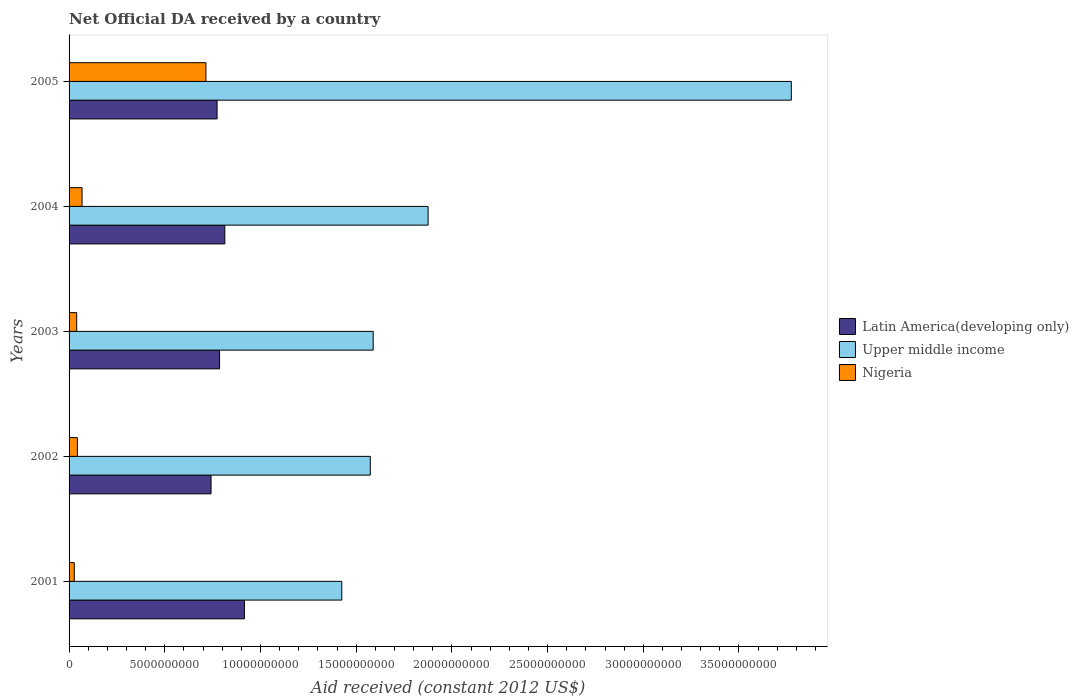How many groups of bars are there?
Offer a terse response. 5. How many bars are there on the 2nd tick from the top?
Your response must be concise. 3. What is the label of the 2nd group of bars from the top?
Offer a terse response. 2004. In how many cases, is the number of bars for a given year not equal to the number of legend labels?
Provide a short and direct response. 0. What is the net official development assistance aid received in Latin America(developing only) in 2004?
Offer a very short reply. 8.14e+09. Across all years, what is the maximum net official development assistance aid received in Nigeria?
Your answer should be compact. 7.15e+09. Across all years, what is the minimum net official development assistance aid received in Latin America(developing only)?
Provide a succinct answer. 7.42e+09. In which year was the net official development assistance aid received in Latin America(developing only) minimum?
Keep it short and to the point. 2002. What is the total net official development assistance aid received in Latin America(developing only) in the graph?
Keep it short and to the point. 4.03e+1. What is the difference between the net official development assistance aid received in Nigeria in 2001 and that in 2002?
Your answer should be very brief. -1.63e+08. What is the difference between the net official development assistance aid received in Latin America(developing only) in 2005 and the net official development assistance aid received in Upper middle income in 2001?
Provide a short and direct response. -6.52e+09. What is the average net official development assistance aid received in Latin America(developing only) per year?
Your answer should be very brief. 8.06e+09. In the year 2004, what is the difference between the net official development assistance aid received in Nigeria and net official development assistance aid received in Latin America(developing only)?
Make the answer very short. -7.46e+09. What is the ratio of the net official development assistance aid received in Nigeria in 2001 to that in 2002?
Provide a succinct answer. 0.63. Is the net official development assistance aid received in Upper middle income in 2001 less than that in 2004?
Provide a succinct answer. Yes. Is the difference between the net official development assistance aid received in Nigeria in 2001 and 2002 greater than the difference between the net official development assistance aid received in Latin America(developing only) in 2001 and 2002?
Your answer should be compact. No. What is the difference between the highest and the second highest net official development assistance aid received in Upper middle income?
Ensure brevity in your answer.  1.90e+1. What is the difference between the highest and the lowest net official development assistance aid received in Nigeria?
Provide a succinct answer. 6.88e+09. Is the sum of the net official development assistance aid received in Upper middle income in 2001 and 2004 greater than the maximum net official development assistance aid received in Nigeria across all years?
Offer a terse response. Yes. What does the 1st bar from the top in 2001 represents?
Offer a terse response. Nigeria. What does the 1st bar from the bottom in 2002 represents?
Ensure brevity in your answer.  Latin America(developing only). Is it the case that in every year, the sum of the net official development assistance aid received in Latin America(developing only) and net official development assistance aid received in Upper middle income is greater than the net official development assistance aid received in Nigeria?
Your answer should be compact. Yes. How many bars are there?
Offer a terse response. 15. Are all the bars in the graph horizontal?
Your answer should be very brief. Yes. Are the values on the major ticks of X-axis written in scientific E-notation?
Provide a short and direct response. No. How many legend labels are there?
Your answer should be compact. 3. How are the legend labels stacked?
Give a very brief answer. Vertical. What is the title of the graph?
Your response must be concise. Net Official DA received by a country. What is the label or title of the X-axis?
Your answer should be compact. Aid received (constant 2012 US$). What is the Aid received (constant 2012 US$) of Latin America(developing only) in 2001?
Provide a succinct answer. 9.16e+09. What is the Aid received (constant 2012 US$) in Upper middle income in 2001?
Offer a terse response. 1.42e+1. What is the Aid received (constant 2012 US$) of Nigeria in 2001?
Provide a succinct answer. 2.72e+08. What is the Aid received (constant 2012 US$) of Latin America(developing only) in 2002?
Offer a terse response. 7.42e+09. What is the Aid received (constant 2012 US$) in Upper middle income in 2002?
Make the answer very short. 1.57e+1. What is the Aid received (constant 2012 US$) in Nigeria in 2002?
Offer a terse response. 4.34e+08. What is the Aid received (constant 2012 US$) in Latin America(developing only) in 2003?
Ensure brevity in your answer.  7.86e+09. What is the Aid received (constant 2012 US$) in Upper middle income in 2003?
Offer a very short reply. 1.59e+1. What is the Aid received (constant 2012 US$) in Nigeria in 2003?
Your answer should be compact. 3.99e+08. What is the Aid received (constant 2012 US$) of Latin America(developing only) in 2004?
Your response must be concise. 8.14e+09. What is the Aid received (constant 2012 US$) of Upper middle income in 2004?
Your response must be concise. 1.88e+1. What is the Aid received (constant 2012 US$) in Nigeria in 2004?
Ensure brevity in your answer.  6.79e+08. What is the Aid received (constant 2012 US$) in Latin America(developing only) in 2005?
Your response must be concise. 7.73e+09. What is the Aid received (constant 2012 US$) in Upper middle income in 2005?
Give a very brief answer. 3.77e+1. What is the Aid received (constant 2012 US$) of Nigeria in 2005?
Ensure brevity in your answer.  7.15e+09. Across all years, what is the maximum Aid received (constant 2012 US$) of Latin America(developing only)?
Ensure brevity in your answer.  9.16e+09. Across all years, what is the maximum Aid received (constant 2012 US$) of Upper middle income?
Your answer should be very brief. 3.77e+1. Across all years, what is the maximum Aid received (constant 2012 US$) of Nigeria?
Keep it short and to the point. 7.15e+09. Across all years, what is the minimum Aid received (constant 2012 US$) in Latin America(developing only)?
Give a very brief answer. 7.42e+09. Across all years, what is the minimum Aid received (constant 2012 US$) of Upper middle income?
Provide a short and direct response. 1.42e+1. Across all years, what is the minimum Aid received (constant 2012 US$) of Nigeria?
Offer a terse response. 2.72e+08. What is the total Aid received (constant 2012 US$) in Latin America(developing only) in the graph?
Make the answer very short. 4.03e+1. What is the total Aid received (constant 2012 US$) of Upper middle income in the graph?
Your answer should be very brief. 1.02e+11. What is the total Aid received (constant 2012 US$) in Nigeria in the graph?
Provide a succinct answer. 8.93e+09. What is the difference between the Aid received (constant 2012 US$) in Latin America(developing only) in 2001 and that in 2002?
Provide a short and direct response. 1.74e+09. What is the difference between the Aid received (constant 2012 US$) of Upper middle income in 2001 and that in 2002?
Make the answer very short. -1.49e+09. What is the difference between the Aid received (constant 2012 US$) of Nigeria in 2001 and that in 2002?
Your response must be concise. -1.63e+08. What is the difference between the Aid received (constant 2012 US$) of Latin America(developing only) in 2001 and that in 2003?
Offer a terse response. 1.30e+09. What is the difference between the Aid received (constant 2012 US$) in Upper middle income in 2001 and that in 2003?
Offer a very short reply. -1.64e+09. What is the difference between the Aid received (constant 2012 US$) in Nigeria in 2001 and that in 2003?
Your response must be concise. -1.27e+08. What is the difference between the Aid received (constant 2012 US$) in Latin America(developing only) in 2001 and that in 2004?
Give a very brief answer. 1.03e+09. What is the difference between the Aid received (constant 2012 US$) of Upper middle income in 2001 and that in 2004?
Your answer should be very brief. -4.51e+09. What is the difference between the Aid received (constant 2012 US$) of Nigeria in 2001 and that in 2004?
Your answer should be compact. -4.07e+08. What is the difference between the Aid received (constant 2012 US$) in Latin America(developing only) in 2001 and that in 2005?
Offer a terse response. 1.43e+09. What is the difference between the Aid received (constant 2012 US$) of Upper middle income in 2001 and that in 2005?
Keep it short and to the point. -2.35e+1. What is the difference between the Aid received (constant 2012 US$) in Nigeria in 2001 and that in 2005?
Offer a terse response. -6.88e+09. What is the difference between the Aid received (constant 2012 US$) of Latin America(developing only) in 2002 and that in 2003?
Offer a terse response. -4.43e+08. What is the difference between the Aid received (constant 2012 US$) in Upper middle income in 2002 and that in 2003?
Provide a succinct answer. -1.50e+08. What is the difference between the Aid received (constant 2012 US$) in Nigeria in 2002 and that in 2003?
Make the answer very short. 3.58e+07. What is the difference between the Aid received (constant 2012 US$) of Latin America(developing only) in 2002 and that in 2004?
Your answer should be very brief. -7.19e+08. What is the difference between the Aid received (constant 2012 US$) of Upper middle income in 2002 and that in 2004?
Provide a succinct answer. -3.02e+09. What is the difference between the Aid received (constant 2012 US$) of Nigeria in 2002 and that in 2004?
Your answer should be very brief. -2.44e+08. What is the difference between the Aid received (constant 2012 US$) of Latin America(developing only) in 2002 and that in 2005?
Give a very brief answer. -3.15e+08. What is the difference between the Aid received (constant 2012 US$) in Upper middle income in 2002 and that in 2005?
Ensure brevity in your answer.  -2.20e+1. What is the difference between the Aid received (constant 2012 US$) in Nigeria in 2002 and that in 2005?
Offer a very short reply. -6.72e+09. What is the difference between the Aid received (constant 2012 US$) in Latin America(developing only) in 2003 and that in 2004?
Your answer should be compact. -2.75e+08. What is the difference between the Aid received (constant 2012 US$) in Upper middle income in 2003 and that in 2004?
Provide a succinct answer. -2.87e+09. What is the difference between the Aid received (constant 2012 US$) in Nigeria in 2003 and that in 2004?
Offer a terse response. -2.80e+08. What is the difference between the Aid received (constant 2012 US$) in Latin America(developing only) in 2003 and that in 2005?
Offer a terse response. 1.29e+08. What is the difference between the Aid received (constant 2012 US$) in Upper middle income in 2003 and that in 2005?
Give a very brief answer. -2.18e+1. What is the difference between the Aid received (constant 2012 US$) in Nigeria in 2003 and that in 2005?
Your answer should be compact. -6.75e+09. What is the difference between the Aid received (constant 2012 US$) of Latin America(developing only) in 2004 and that in 2005?
Ensure brevity in your answer.  4.04e+08. What is the difference between the Aid received (constant 2012 US$) of Upper middle income in 2004 and that in 2005?
Provide a succinct answer. -1.90e+1. What is the difference between the Aid received (constant 2012 US$) in Nigeria in 2004 and that in 2005?
Keep it short and to the point. -6.47e+09. What is the difference between the Aid received (constant 2012 US$) in Latin America(developing only) in 2001 and the Aid received (constant 2012 US$) in Upper middle income in 2002?
Offer a very short reply. -6.58e+09. What is the difference between the Aid received (constant 2012 US$) in Latin America(developing only) in 2001 and the Aid received (constant 2012 US$) in Nigeria in 2002?
Provide a short and direct response. 8.73e+09. What is the difference between the Aid received (constant 2012 US$) of Upper middle income in 2001 and the Aid received (constant 2012 US$) of Nigeria in 2002?
Give a very brief answer. 1.38e+1. What is the difference between the Aid received (constant 2012 US$) in Latin America(developing only) in 2001 and the Aid received (constant 2012 US$) in Upper middle income in 2003?
Provide a short and direct response. -6.73e+09. What is the difference between the Aid received (constant 2012 US$) of Latin America(developing only) in 2001 and the Aid received (constant 2012 US$) of Nigeria in 2003?
Ensure brevity in your answer.  8.76e+09. What is the difference between the Aid received (constant 2012 US$) in Upper middle income in 2001 and the Aid received (constant 2012 US$) in Nigeria in 2003?
Provide a succinct answer. 1.38e+1. What is the difference between the Aid received (constant 2012 US$) of Latin America(developing only) in 2001 and the Aid received (constant 2012 US$) of Upper middle income in 2004?
Your response must be concise. -9.59e+09. What is the difference between the Aid received (constant 2012 US$) of Latin America(developing only) in 2001 and the Aid received (constant 2012 US$) of Nigeria in 2004?
Your answer should be compact. 8.48e+09. What is the difference between the Aid received (constant 2012 US$) of Upper middle income in 2001 and the Aid received (constant 2012 US$) of Nigeria in 2004?
Ensure brevity in your answer.  1.36e+1. What is the difference between the Aid received (constant 2012 US$) of Latin America(developing only) in 2001 and the Aid received (constant 2012 US$) of Upper middle income in 2005?
Offer a very short reply. -2.86e+1. What is the difference between the Aid received (constant 2012 US$) of Latin America(developing only) in 2001 and the Aid received (constant 2012 US$) of Nigeria in 2005?
Your answer should be compact. 2.01e+09. What is the difference between the Aid received (constant 2012 US$) of Upper middle income in 2001 and the Aid received (constant 2012 US$) of Nigeria in 2005?
Offer a very short reply. 7.10e+09. What is the difference between the Aid received (constant 2012 US$) in Latin America(developing only) in 2002 and the Aid received (constant 2012 US$) in Upper middle income in 2003?
Provide a succinct answer. -8.47e+09. What is the difference between the Aid received (constant 2012 US$) of Latin America(developing only) in 2002 and the Aid received (constant 2012 US$) of Nigeria in 2003?
Your response must be concise. 7.02e+09. What is the difference between the Aid received (constant 2012 US$) in Upper middle income in 2002 and the Aid received (constant 2012 US$) in Nigeria in 2003?
Make the answer very short. 1.53e+1. What is the difference between the Aid received (constant 2012 US$) of Latin America(developing only) in 2002 and the Aid received (constant 2012 US$) of Upper middle income in 2004?
Keep it short and to the point. -1.13e+1. What is the difference between the Aid received (constant 2012 US$) in Latin America(developing only) in 2002 and the Aid received (constant 2012 US$) in Nigeria in 2004?
Offer a terse response. 6.74e+09. What is the difference between the Aid received (constant 2012 US$) in Upper middle income in 2002 and the Aid received (constant 2012 US$) in Nigeria in 2004?
Give a very brief answer. 1.51e+1. What is the difference between the Aid received (constant 2012 US$) of Latin America(developing only) in 2002 and the Aid received (constant 2012 US$) of Upper middle income in 2005?
Provide a succinct answer. -3.03e+1. What is the difference between the Aid received (constant 2012 US$) in Latin America(developing only) in 2002 and the Aid received (constant 2012 US$) in Nigeria in 2005?
Make the answer very short. 2.68e+08. What is the difference between the Aid received (constant 2012 US$) in Upper middle income in 2002 and the Aid received (constant 2012 US$) in Nigeria in 2005?
Your response must be concise. 8.59e+09. What is the difference between the Aid received (constant 2012 US$) in Latin America(developing only) in 2003 and the Aid received (constant 2012 US$) in Upper middle income in 2004?
Your answer should be very brief. -1.09e+1. What is the difference between the Aid received (constant 2012 US$) of Latin America(developing only) in 2003 and the Aid received (constant 2012 US$) of Nigeria in 2004?
Offer a terse response. 7.18e+09. What is the difference between the Aid received (constant 2012 US$) of Upper middle income in 2003 and the Aid received (constant 2012 US$) of Nigeria in 2004?
Provide a succinct answer. 1.52e+1. What is the difference between the Aid received (constant 2012 US$) in Latin America(developing only) in 2003 and the Aid received (constant 2012 US$) in Upper middle income in 2005?
Your answer should be very brief. -2.99e+1. What is the difference between the Aid received (constant 2012 US$) in Latin America(developing only) in 2003 and the Aid received (constant 2012 US$) in Nigeria in 2005?
Your answer should be compact. 7.12e+08. What is the difference between the Aid received (constant 2012 US$) of Upper middle income in 2003 and the Aid received (constant 2012 US$) of Nigeria in 2005?
Your answer should be compact. 8.74e+09. What is the difference between the Aid received (constant 2012 US$) in Latin America(developing only) in 2004 and the Aid received (constant 2012 US$) in Upper middle income in 2005?
Keep it short and to the point. -2.96e+1. What is the difference between the Aid received (constant 2012 US$) in Latin America(developing only) in 2004 and the Aid received (constant 2012 US$) in Nigeria in 2005?
Ensure brevity in your answer.  9.87e+08. What is the difference between the Aid received (constant 2012 US$) of Upper middle income in 2004 and the Aid received (constant 2012 US$) of Nigeria in 2005?
Make the answer very short. 1.16e+1. What is the average Aid received (constant 2012 US$) of Latin America(developing only) per year?
Offer a very short reply. 8.06e+09. What is the average Aid received (constant 2012 US$) in Upper middle income per year?
Your answer should be very brief. 2.05e+1. What is the average Aid received (constant 2012 US$) in Nigeria per year?
Provide a succinct answer. 1.79e+09. In the year 2001, what is the difference between the Aid received (constant 2012 US$) in Latin America(developing only) and Aid received (constant 2012 US$) in Upper middle income?
Give a very brief answer. -5.09e+09. In the year 2001, what is the difference between the Aid received (constant 2012 US$) of Latin America(developing only) and Aid received (constant 2012 US$) of Nigeria?
Your response must be concise. 8.89e+09. In the year 2001, what is the difference between the Aid received (constant 2012 US$) in Upper middle income and Aid received (constant 2012 US$) in Nigeria?
Your response must be concise. 1.40e+1. In the year 2002, what is the difference between the Aid received (constant 2012 US$) in Latin America(developing only) and Aid received (constant 2012 US$) in Upper middle income?
Make the answer very short. -8.32e+09. In the year 2002, what is the difference between the Aid received (constant 2012 US$) of Latin America(developing only) and Aid received (constant 2012 US$) of Nigeria?
Provide a succinct answer. 6.98e+09. In the year 2002, what is the difference between the Aid received (constant 2012 US$) of Upper middle income and Aid received (constant 2012 US$) of Nigeria?
Offer a terse response. 1.53e+1. In the year 2003, what is the difference between the Aid received (constant 2012 US$) in Latin America(developing only) and Aid received (constant 2012 US$) in Upper middle income?
Offer a terse response. -8.03e+09. In the year 2003, what is the difference between the Aid received (constant 2012 US$) of Latin America(developing only) and Aid received (constant 2012 US$) of Nigeria?
Give a very brief answer. 7.46e+09. In the year 2003, what is the difference between the Aid received (constant 2012 US$) in Upper middle income and Aid received (constant 2012 US$) in Nigeria?
Ensure brevity in your answer.  1.55e+1. In the year 2004, what is the difference between the Aid received (constant 2012 US$) in Latin America(developing only) and Aid received (constant 2012 US$) in Upper middle income?
Ensure brevity in your answer.  -1.06e+1. In the year 2004, what is the difference between the Aid received (constant 2012 US$) of Latin America(developing only) and Aid received (constant 2012 US$) of Nigeria?
Give a very brief answer. 7.46e+09. In the year 2004, what is the difference between the Aid received (constant 2012 US$) in Upper middle income and Aid received (constant 2012 US$) in Nigeria?
Your answer should be compact. 1.81e+1. In the year 2005, what is the difference between the Aid received (constant 2012 US$) in Latin America(developing only) and Aid received (constant 2012 US$) in Upper middle income?
Keep it short and to the point. -3.00e+1. In the year 2005, what is the difference between the Aid received (constant 2012 US$) of Latin America(developing only) and Aid received (constant 2012 US$) of Nigeria?
Your response must be concise. 5.83e+08. In the year 2005, what is the difference between the Aid received (constant 2012 US$) in Upper middle income and Aid received (constant 2012 US$) in Nigeria?
Your answer should be compact. 3.06e+1. What is the ratio of the Aid received (constant 2012 US$) in Latin America(developing only) in 2001 to that in 2002?
Offer a very short reply. 1.24. What is the ratio of the Aid received (constant 2012 US$) in Upper middle income in 2001 to that in 2002?
Provide a short and direct response. 0.91. What is the ratio of the Aid received (constant 2012 US$) of Nigeria in 2001 to that in 2002?
Give a very brief answer. 0.63. What is the ratio of the Aid received (constant 2012 US$) of Latin America(developing only) in 2001 to that in 2003?
Make the answer very short. 1.17. What is the ratio of the Aid received (constant 2012 US$) of Upper middle income in 2001 to that in 2003?
Offer a terse response. 0.9. What is the ratio of the Aid received (constant 2012 US$) in Nigeria in 2001 to that in 2003?
Give a very brief answer. 0.68. What is the ratio of the Aid received (constant 2012 US$) of Latin America(developing only) in 2001 to that in 2004?
Ensure brevity in your answer.  1.13. What is the ratio of the Aid received (constant 2012 US$) in Upper middle income in 2001 to that in 2004?
Provide a succinct answer. 0.76. What is the ratio of the Aid received (constant 2012 US$) of Nigeria in 2001 to that in 2004?
Make the answer very short. 0.4. What is the ratio of the Aid received (constant 2012 US$) in Latin America(developing only) in 2001 to that in 2005?
Your answer should be very brief. 1.18. What is the ratio of the Aid received (constant 2012 US$) in Upper middle income in 2001 to that in 2005?
Your response must be concise. 0.38. What is the ratio of the Aid received (constant 2012 US$) in Nigeria in 2001 to that in 2005?
Make the answer very short. 0.04. What is the ratio of the Aid received (constant 2012 US$) of Latin America(developing only) in 2002 to that in 2003?
Your answer should be very brief. 0.94. What is the ratio of the Aid received (constant 2012 US$) of Upper middle income in 2002 to that in 2003?
Give a very brief answer. 0.99. What is the ratio of the Aid received (constant 2012 US$) of Nigeria in 2002 to that in 2003?
Ensure brevity in your answer.  1.09. What is the ratio of the Aid received (constant 2012 US$) in Latin America(developing only) in 2002 to that in 2004?
Provide a succinct answer. 0.91. What is the ratio of the Aid received (constant 2012 US$) in Upper middle income in 2002 to that in 2004?
Your response must be concise. 0.84. What is the ratio of the Aid received (constant 2012 US$) in Nigeria in 2002 to that in 2004?
Provide a short and direct response. 0.64. What is the ratio of the Aid received (constant 2012 US$) of Latin America(developing only) in 2002 to that in 2005?
Offer a terse response. 0.96. What is the ratio of the Aid received (constant 2012 US$) of Upper middle income in 2002 to that in 2005?
Offer a very short reply. 0.42. What is the ratio of the Aid received (constant 2012 US$) in Nigeria in 2002 to that in 2005?
Provide a short and direct response. 0.06. What is the ratio of the Aid received (constant 2012 US$) of Latin America(developing only) in 2003 to that in 2004?
Offer a very short reply. 0.97. What is the ratio of the Aid received (constant 2012 US$) in Upper middle income in 2003 to that in 2004?
Offer a terse response. 0.85. What is the ratio of the Aid received (constant 2012 US$) in Nigeria in 2003 to that in 2004?
Offer a terse response. 0.59. What is the ratio of the Aid received (constant 2012 US$) in Latin America(developing only) in 2003 to that in 2005?
Give a very brief answer. 1.02. What is the ratio of the Aid received (constant 2012 US$) of Upper middle income in 2003 to that in 2005?
Offer a terse response. 0.42. What is the ratio of the Aid received (constant 2012 US$) of Nigeria in 2003 to that in 2005?
Your response must be concise. 0.06. What is the ratio of the Aid received (constant 2012 US$) in Latin America(developing only) in 2004 to that in 2005?
Provide a short and direct response. 1.05. What is the ratio of the Aid received (constant 2012 US$) of Upper middle income in 2004 to that in 2005?
Keep it short and to the point. 0.5. What is the ratio of the Aid received (constant 2012 US$) of Nigeria in 2004 to that in 2005?
Give a very brief answer. 0.09. What is the difference between the highest and the second highest Aid received (constant 2012 US$) in Latin America(developing only)?
Your response must be concise. 1.03e+09. What is the difference between the highest and the second highest Aid received (constant 2012 US$) of Upper middle income?
Offer a terse response. 1.90e+1. What is the difference between the highest and the second highest Aid received (constant 2012 US$) in Nigeria?
Ensure brevity in your answer.  6.47e+09. What is the difference between the highest and the lowest Aid received (constant 2012 US$) in Latin America(developing only)?
Your response must be concise. 1.74e+09. What is the difference between the highest and the lowest Aid received (constant 2012 US$) of Upper middle income?
Your response must be concise. 2.35e+1. What is the difference between the highest and the lowest Aid received (constant 2012 US$) of Nigeria?
Make the answer very short. 6.88e+09. 